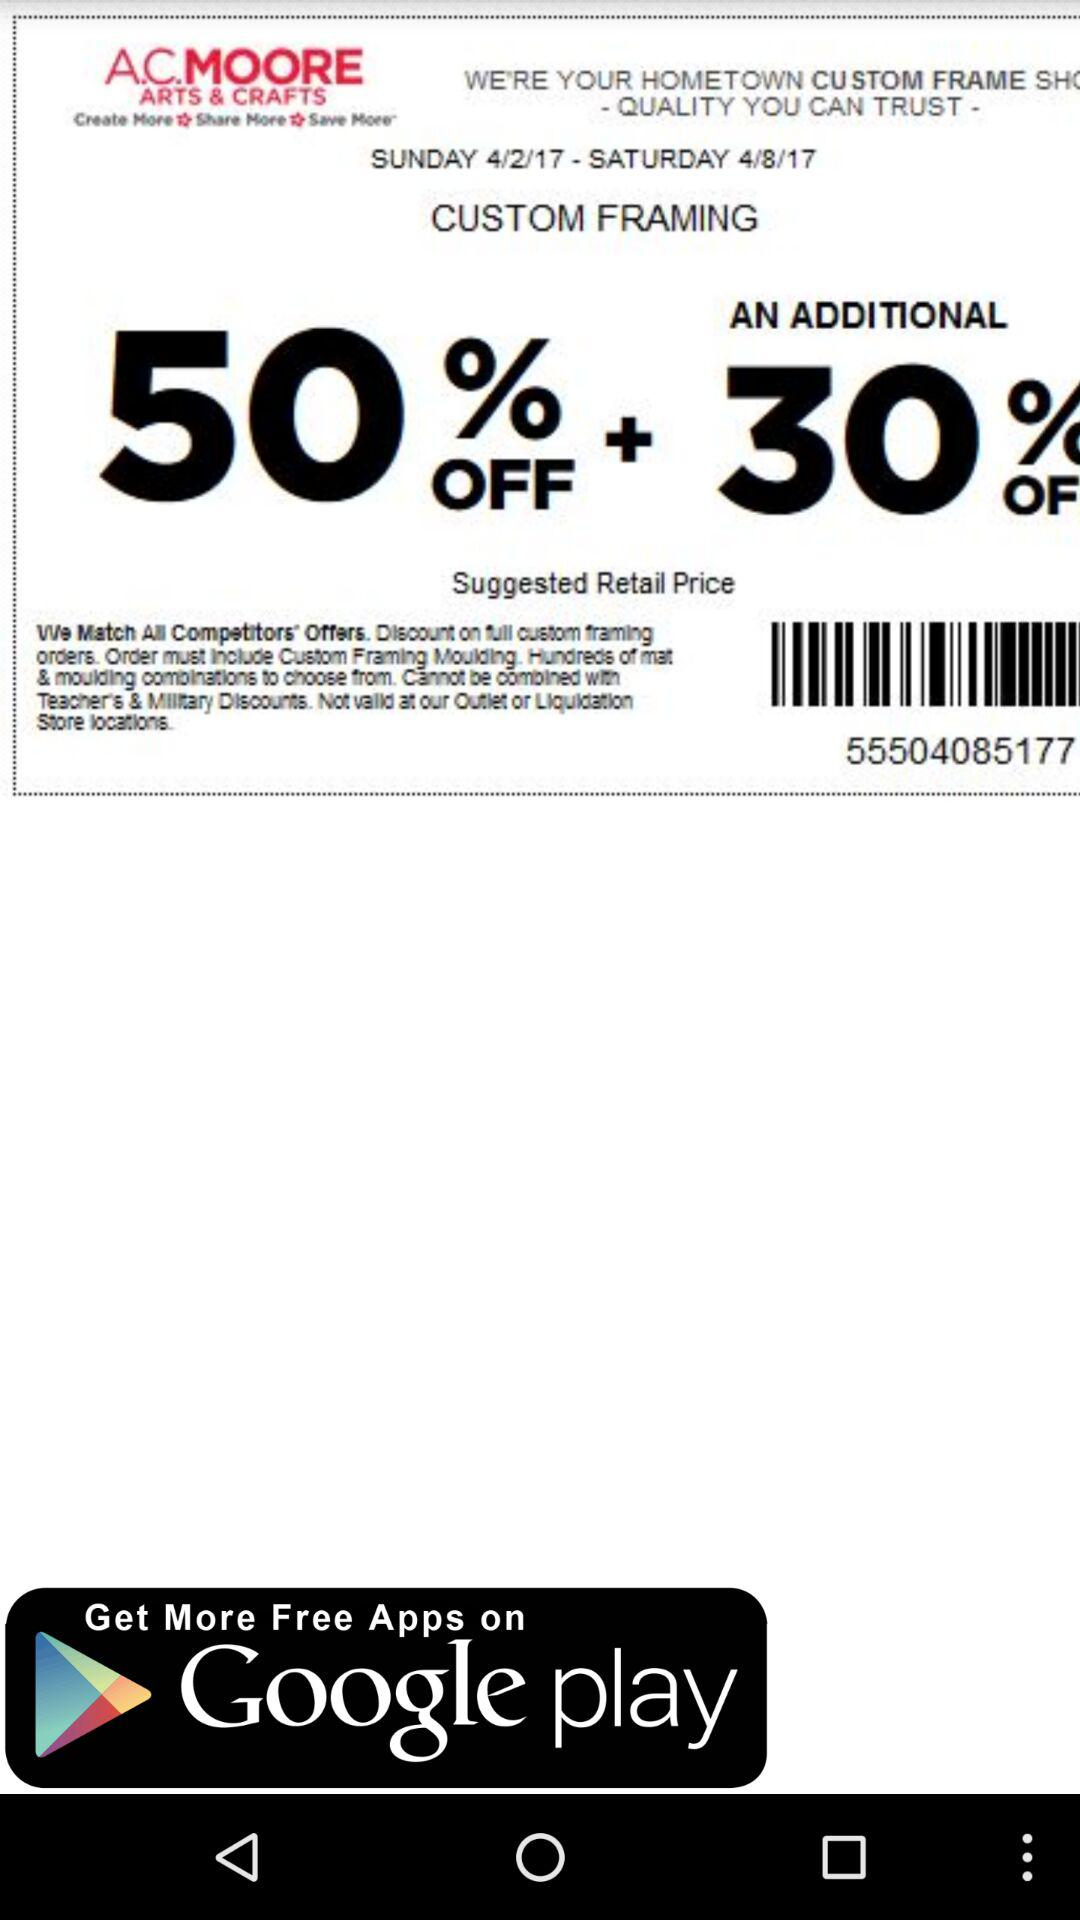What is the date range of the offer? The date range of the offer is from Sunday, April 2, 2017 to Saturday, April 8, 2017. 